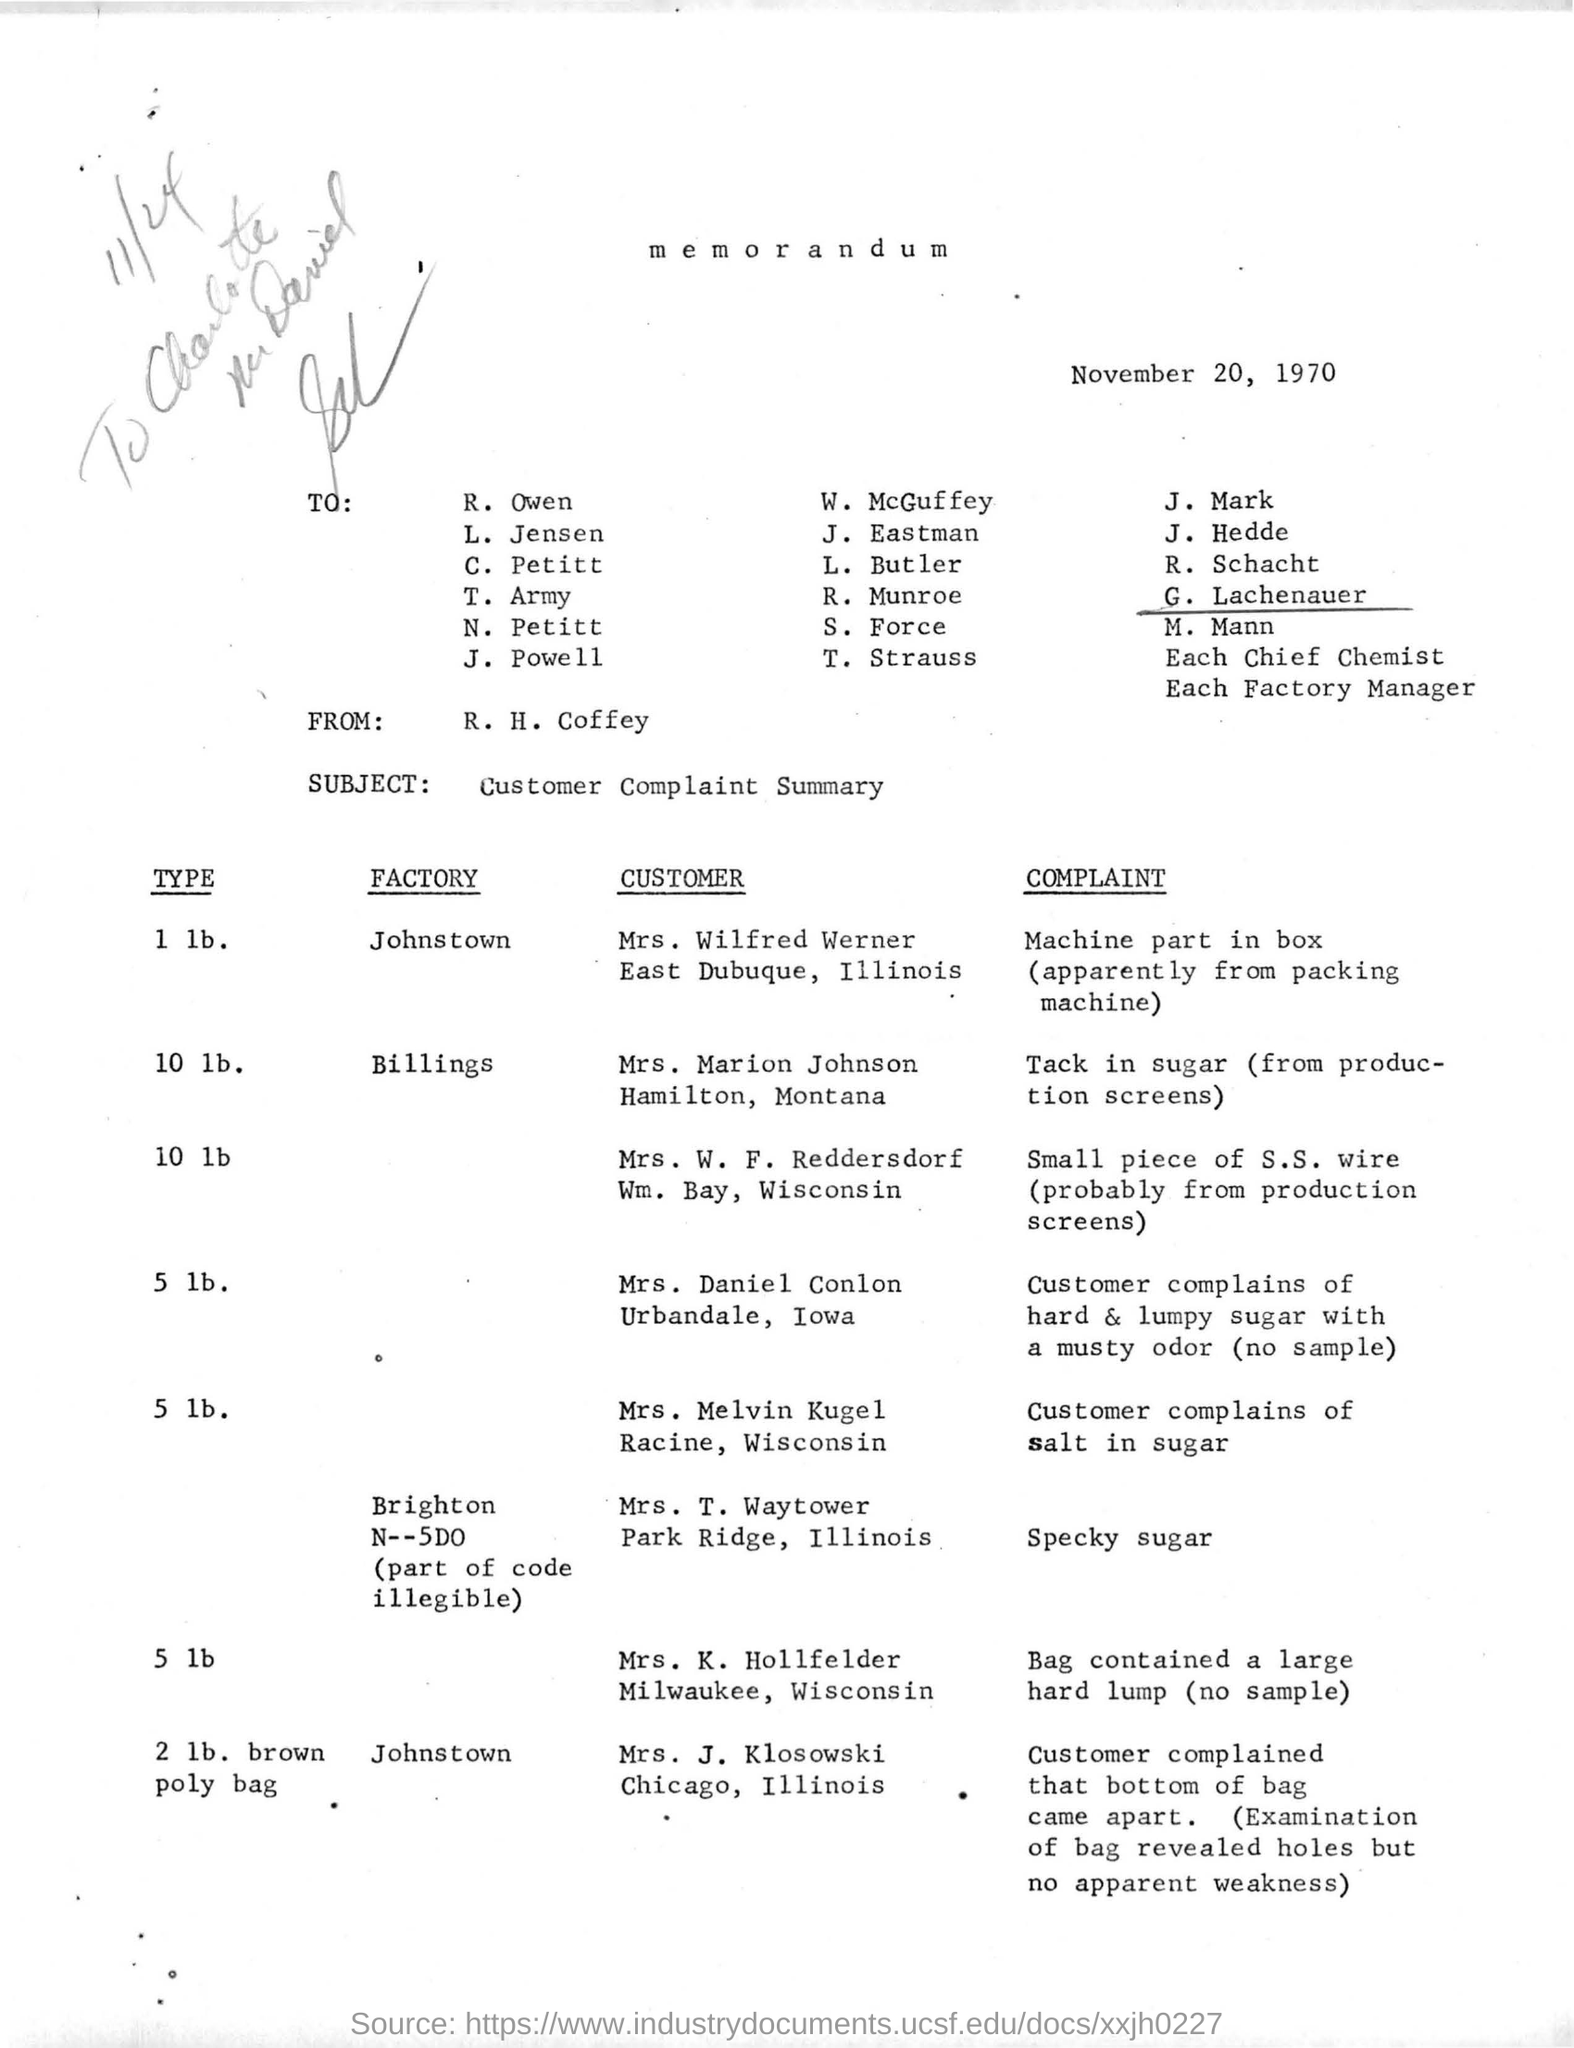Who is the memorandum from?
Provide a short and direct response. R. H. Coffey. What is the subject of the memorandum?
Your answer should be very brief. Customer Complaint Summary. 